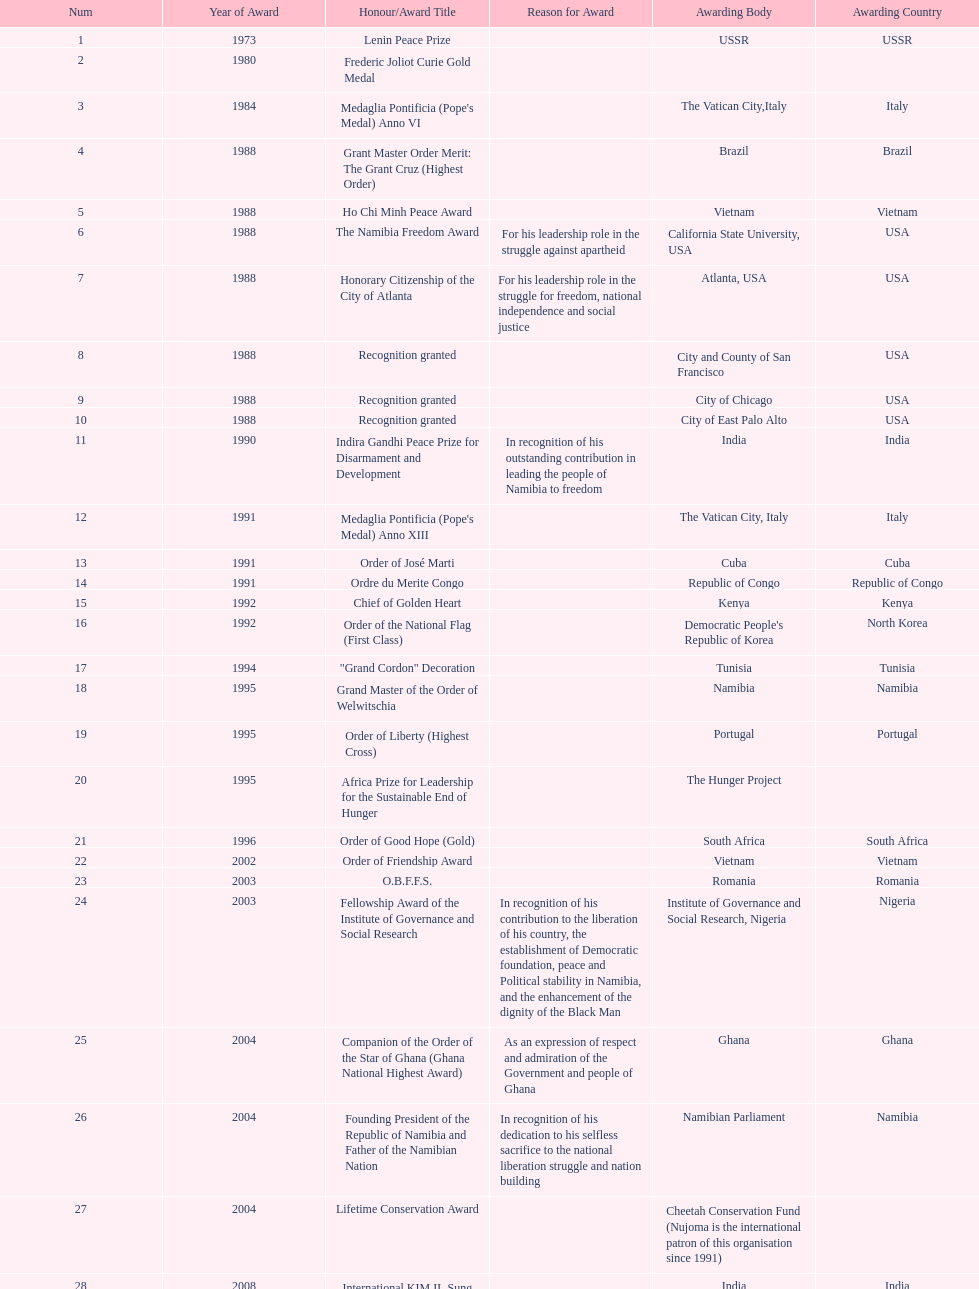What award was won previously just before the medaglia pontificia anno xiii was awarded? Indira Gandhi Peace Prize for Disarmament and Development. 